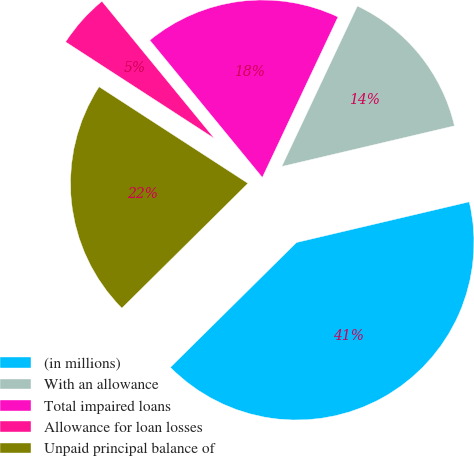Convert chart to OTSL. <chart><loc_0><loc_0><loc_500><loc_500><pie_chart><fcel>(in millions)<fcel>With an allowance<fcel>Total impaired loans<fcel>Allowance for loan losses<fcel>Unpaid principal balance of<nl><fcel>41.26%<fcel>14.31%<fcel>17.94%<fcel>4.91%<fcel>21.58%<nl></chart> 